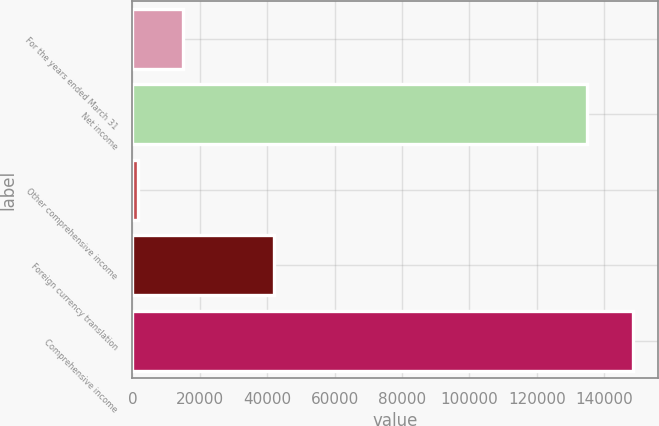Convert chart to OTSL. <chart><loc_0><loc_0><loc_500><loc_500><bar_chart><fcel>For the years ended March 31<fcel>Net income<fcel>Other comprehensive income<fcel>Foreign currency translation<fcel>Comprehensive income<nl><fcel>15162.7<fcel>135057<fcel>1657<fcel>42174.1<fcel>148563<nl></chart> 